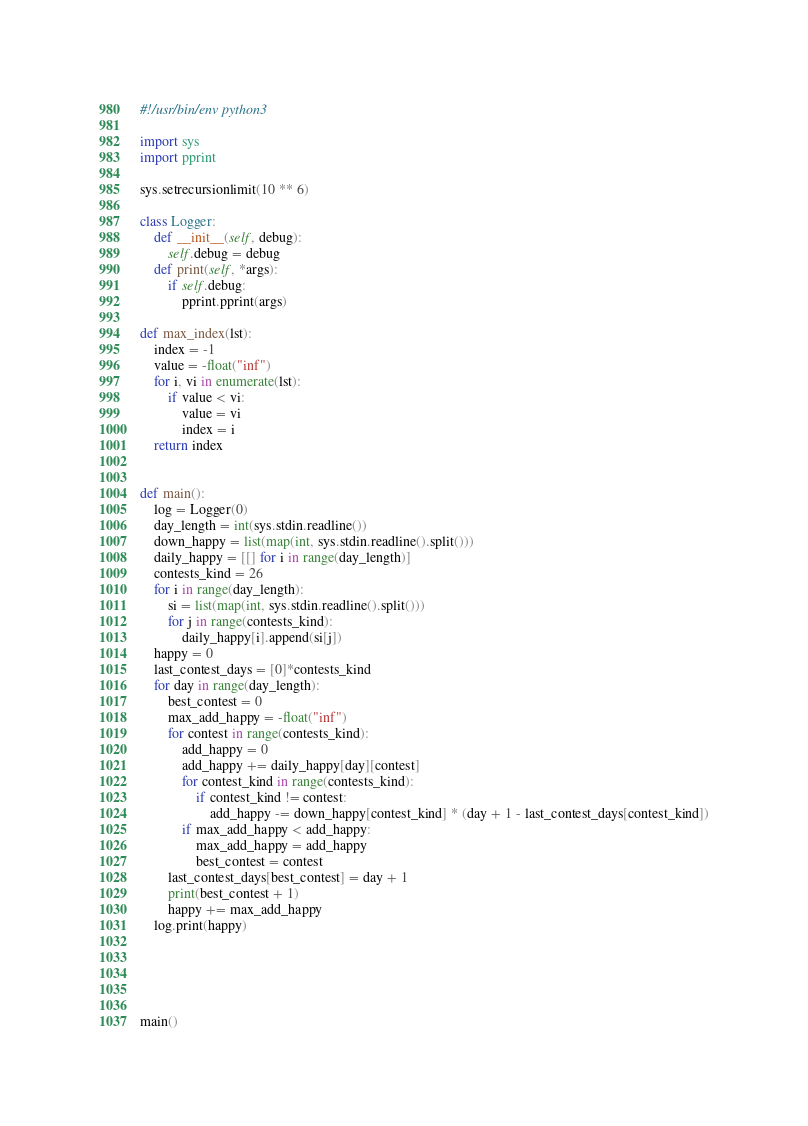Convert code to text. <code><loc_0><loc_0><loc_500><loc_500><_Python_>#!/usr/bin/env python3

import sys
import pprint

sys.setrecursionlimit(10 ** 6)

class Logger:
	def __init__(self, debug):
		self.debug = debug
	def print(self, *args):
		if self.debug:
			pprint.pprint(args)

def max_index(lst):
	index = -1
	value = -float("inf")
	for i, vi in enumerate(lst):
		if value < vi:
			value = vi
			index = i
	return index


def main():
	log = Logger(0)
	day_length = int(sys.stdin.readline())
	down_happy = list(map(int, sys.stdin.readline().split()))
	daily_happy = [[] for i in range(day_length)]
	contests_kind = 26
	for i in range(day_length):
		si = list(map(int, sys.stdin.readline().split()))
		for j in range(contests_kind):
			daily_happy[i].append(si[j])
	happy = 0
	last_contest_days = [0]*contests_kind
	for day in range(day_length):
		best_contest = 0
		max_add_happy = -float("inf")
		for contest in range(contests_kind):
			add_happy = 0
			add_happy += daily_happy[day][contest]
			for contest_kind in range(contests_kind):
				if contest_kind != contest:
					add_happy -= down_happy[contest_kind] * (day + 1 - last_contest_days[contest_kind])
			if max_add_happy < add_happy:
				max_add_happy = add_happy
				best_contest = contest
		last_contest_days[best_contest] = day + 1
		print(best_contest + 1)
		happy += max_add_happy
	log.print(happy)





main()</code> 